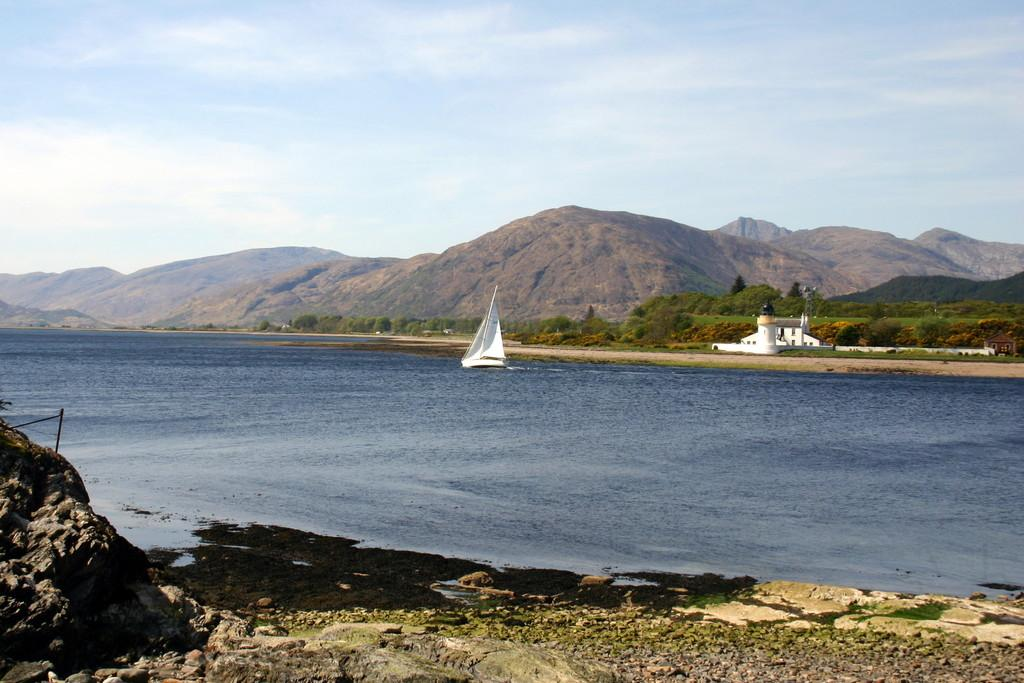What is the main feature of the image? There is water in the image. What is floating on the water? There is a white-colored boat on the water. What type of vegetation can be seen in the image? There are green-colored trees in the image. What geographical feature is visible in the background? There are mountains visible in the image. What is visible at the top of the image? The sky is visible at the top of the image. What book is the person reading while sitting in the boat? There is no person visible in the image, and therefore no one is reading a book. 